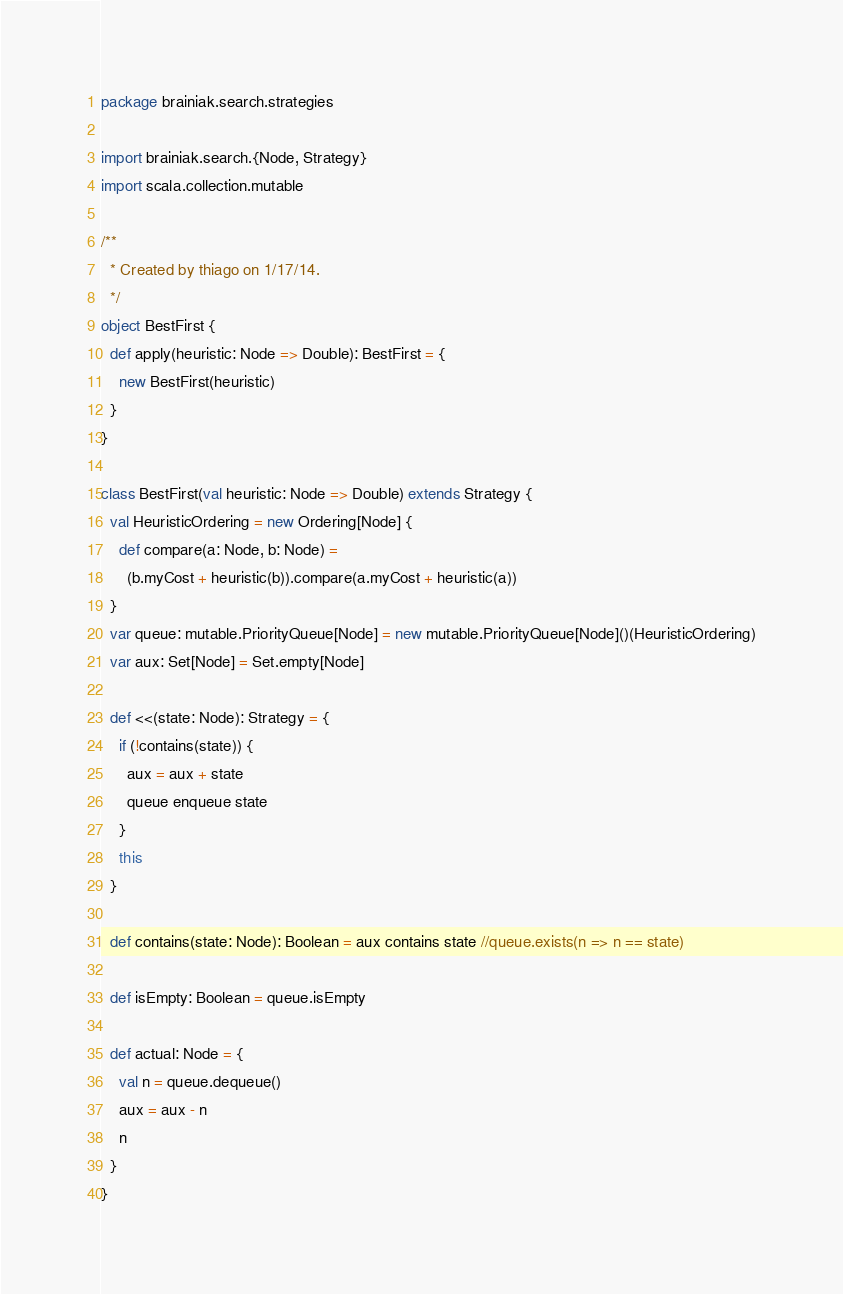<code> <loc_0><loc_0><loc_500><loc_500><_Scala_>package brainiak.search.strategies

import brainiak.search.{Node, Strategy}
import scala.collection.mutable

/**
  * Created by thiago on 1/17/14.
  */
object BestFirst {
  def apply(heuristic: Node => Double): BestFirst = {
    new BestFirst(heuristic)
  }
}

class BestFirst(val heuristic: Node => Double) extends Strategy {
  val HeuristicOrdering = new Ordering[Node] {
    def compare(a: Node, b: Node) =
      (b.myCost + heuristic(b)).compare(a.myCost + heuristic(a))
  }
  var queue: mutable.PriorityQueue[Node] = new mutable.PriorityQueue[Node]()(HeuristicOrdering)
  var aux: Set[Node] = Set.empty[Node]

  def <<(state: Node): Strategy = {
    if (!contains(state)) {
      aux = aux + state
      queue enqueue state
    }
    this
  }

  def contains(state: Node): Boolean = aux contains state //queue.exists(n => n == state)

  def isEmpty: Boolean = queue.isEmpty

  def actual: Node = {
    val n = queue.dequeue()
    aux = aux - n
    n
  }
}
</code> 